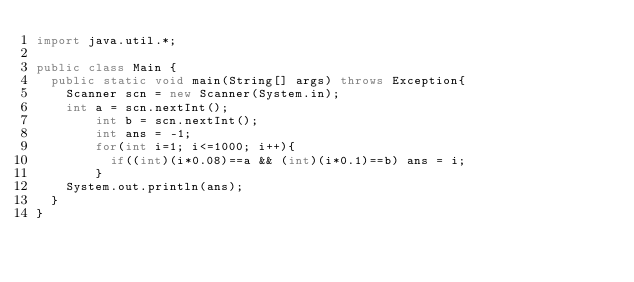<code> <loc_0><loc_0><loc_500><loc_500><_Java_>import java.util.*;

public class Main {
	public static void main(String[] args) throws Exception{
		Scanner scn = new Scanner(System.in);
		int a = scn.nextInt();
      	int b = scn.nextInt();
      	int ans = -1;
      	for(int i=1; i<=1000; i++){
          if((int)(i*0.08)==a && (int)(i*0.1)==b) ans = i;
        }
		System.out.println(ans);
	}
}
</code> 